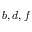<formula> <loc_0><loc_0><loc_500><loc_500>b , d , f</formula> 